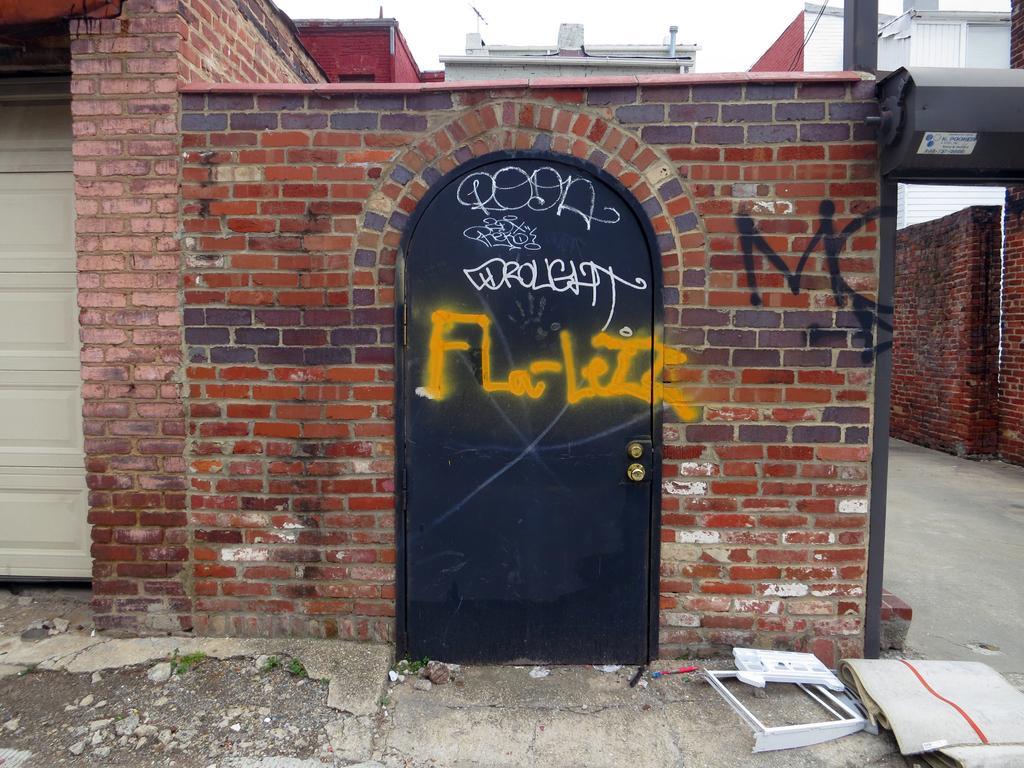Could you give a brief overview of what you see in this image? In the center of the image there is a door. There is a wall. In front of the image there are some objects. On the left side of the image there is a white door. On the right side of the image there is a road. There are walls. In the background of the image there are buildings and sky. 